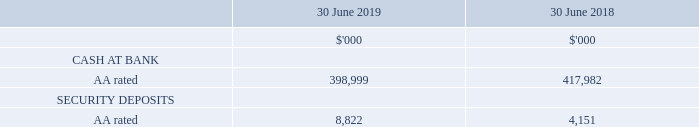15 Financial risk management (continued)
(b) Credit risk
Credit risk arises from cash and cash equivalents, and trade and other receivables.
(i) Cash and cash equivalents and security deposits
Deposits are placed with Australian banks or independently rated parties with a minimum rating of ‘BBB+’. To reduce exposure deposits are placed with a variety of financial institutions.
The credit quality of financial assets can be assessed by reference to external credit ratings (if available) or to historical information about counterparty default rates:
In determining the credit quality of these financial assets, NEXTDC has used the long-term rating from Standard & Poor’s as of July 2019.
How much was the security deposits in 2019?
Answer scale should be: thousand. 8,822. How much cash was at bank in 2019?
Answer scale should be: thousand. 398,999. How much was the security deposits in 2018?
Answer scale should be: thousand. 4,151. What was the percentage change in AA rated security deposits between 2018 and 2019?
Answer scale should be: percent. (8,822 - 4,151) / 4,151 
Answer: 112.53. Cash at bank or security deposits, which one was greater in 2019? 398,999 vs 8,822
Answer: cash at bank. What was the average difference between cash at bank and security deposits for both years?
Answer scale should be: thousand. ((398,999 - 8,822) + (417,982 - 4,151)) / 2 
Answer: 402004. 